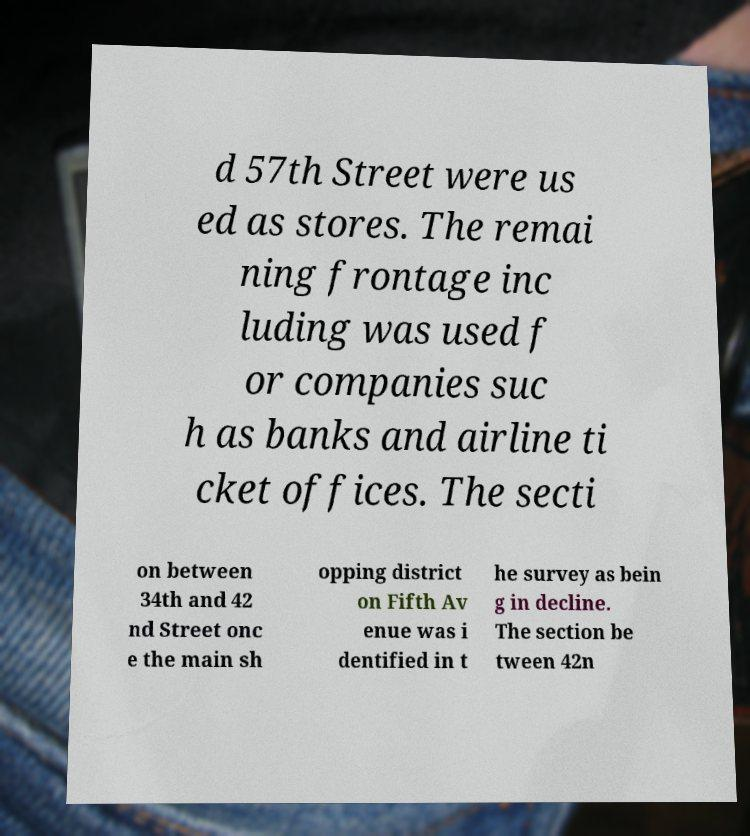There's text embedded in this image that I need extracted. Can you transcribe it verbatim? d 57th Street were us ed as stores. The remai ning frontage inc luding was used f or companies suc h as banks and airline ti cket offices. The secti on between 34th and 42 nd Street onc e the main sh opping district on Fifth Av enue was i dentified in t he survey as bein g in decline. The section be tween 42n 